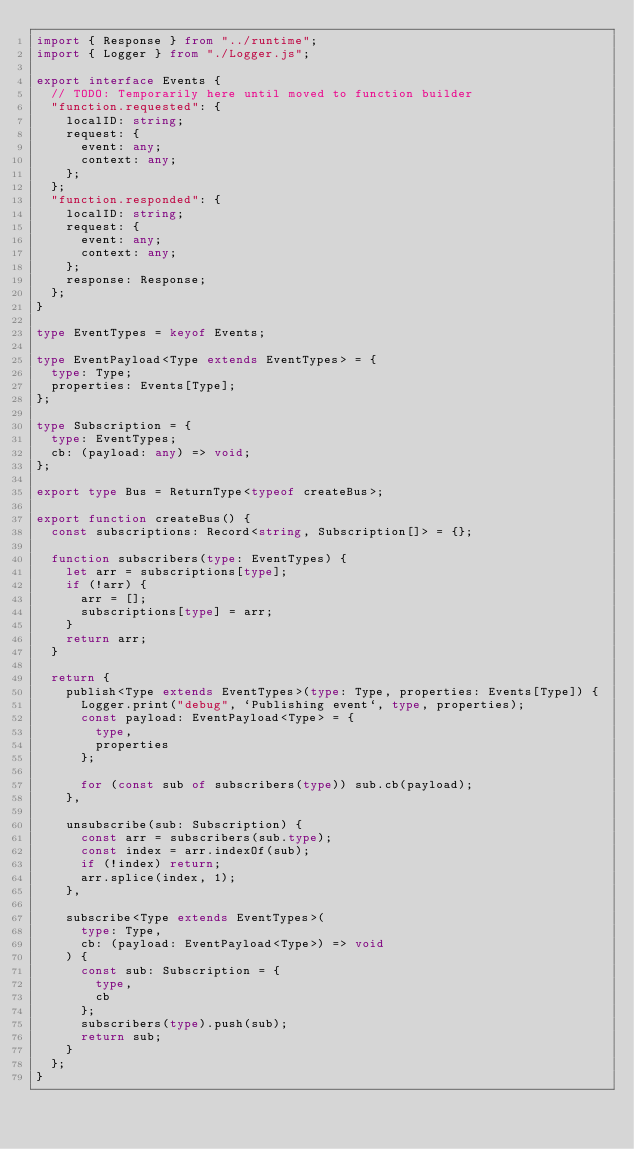<code> <loc_0><loc_0><loc_500><loc_500><_TypeScript_>import { Response } from "../runtime";
import { Logger } from "./Logger.js";

export interface Events {
  // TODO: Temporarily here until moved to function builder
  "function.requested": {
    localID: string;
    request: {
      event: any;
      context: any;
    };
  };
  "function.responded": {
    localID: string;
    request: {
      event: any;
      context: any;
    };
    response: Response;
  };
}

type EventTypes = keyof Events;

type EventPayload<Type extends EventTypes> = {
  type: Type;
  properties: Events[Type];
};

type Subscription = {
  type: EventTypes;
  cb: (payload: any) => void;
};

export type Bus = ReturnType<typeof createBus>;

export function createBus() {
  const subscriptions: Record<string, Subscription[]> = {};

  function subscribers(type: EventTypes) {
    let arr = subscriptions[type];
    if (!arr) {
      arr = [];
      subscriptions[type] = arr;
    }
    return arr;
  }

  return {
    publish<Type extends EventTypes>(type: Type, properties: Events[Type]) {
      Logger.print("debug", `Publishing event`, type, properties);
      const payload: EventPayload<Type> = {
        type,
        properties
      };

      for (const sub of subscribers(type)) sub.cb(payload);
    },

    unsubscribe(sub: Subscription) {
      const arr = subscribers(sub.type);
      const index = arr.indexOf(sub);
      if (!index) return;
      arr.splice(index, 1);
    },

    subscribe<Type extends EventTypes>(
      type: Type,
      cb: (payload: EventPayload<Type>) => void
    ) {
      const sub: Subscription = {
        type,
        cb
      };
      subscribers(type).push(sub);
      return sub;
    }
  };
}
</code> 